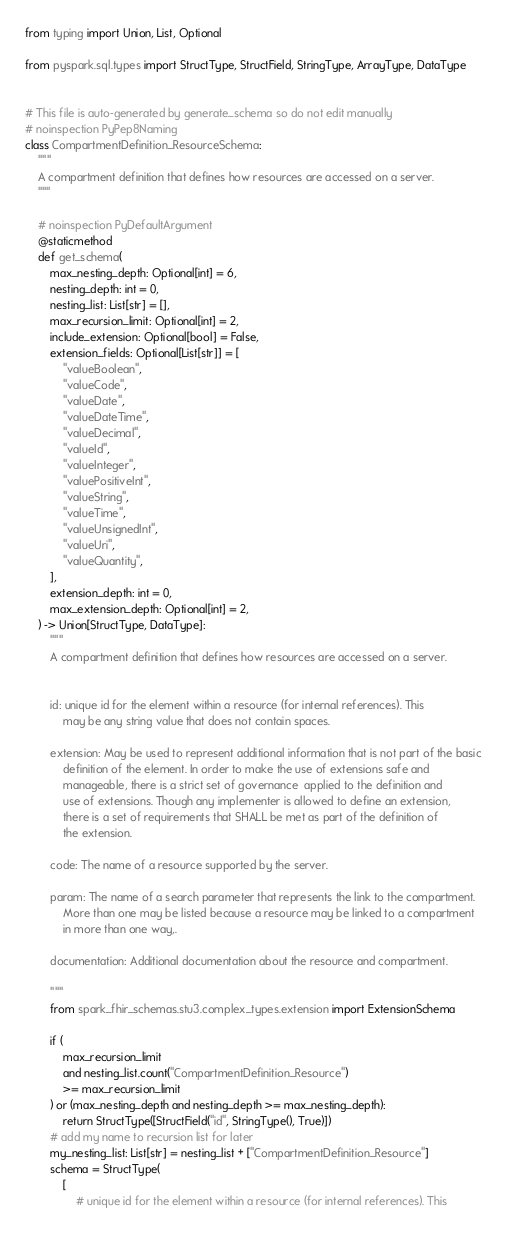<code> <loc_0><loc_0><loc_500><loc_500><_Python_>from typing import Union, List, Optional

from pyspark.sql.types import StructType, StructField, StringType, ArrayType, DataType


# This file is auto-generated by generate_schema so do not edit manually
# noinspection PyPep8Naming
class CompartmentDefinition_ResourceSchema:
    """
    A compartment definition that defines how resources are accessed on a server.
    """

    # noinspection PyDefaultArgument
    @staticmethod
    def get_schema(
        max_nesting_depth: Optional[int] = 6,
        nesting_depth: int = 0,
        nesting_list: List[str] = [],
        max_recursion_limit: Optional[int] = 2,
        include_extension: Optional[bool] = False,
        extension_fields: Optional[List[str]] = [
            "valueBoolean",
            "valueCode",
            "valueDate",
            "valueDateTime",
            "valueDecimal",
            "valueId",
            "valueInteger",
            "valuePositiveInt",
            "valueString",
            "valueTime",
            "valueUnsignedInt",
            "valueUri",
            "valueQuantity",
        ],
        extension_depth: int = 0,
        max_extension_depth: Optional[int] = 2,
    ) -> Union[StructType, DataType]:
        """
        A compartment definition that defines how resources are accessed on a server.


        id: unique id for the element within a resource (for internal references). This
            may be any string value that does not contain spaces.

        extension: May be used to represent additional information that is not part of the basic
            definition of the element. In order to make the use of extensions safe and
            manageable, there is a strict set of governance  applied to the definition and
            use of extensions. Though any implementer is allowed to define an extension,
            there is a set of requirements that SHALL be met as part of the definition of
            the extension.

        code: The name of a resource supported by the server.

        param: The name of a search parameter that represents the link to the compartment.
            More than one may be listed because a resource may be linked to a compartment
            in more than one way,.

        documentation: Additional documentation about the resource and compartment.

        """
        from spark_fhir_schemas.stu3.complex_types.extension import ExtensionSchema

        if (
            max_recursion_limit
            and nesting_list.count("CompartmentDefinition_Resource")
            >= max_recursion_limit
        ) or (max_nesting_depth and nesting_depth >= max_nesting_depth):
            return StructType([StructField("id", StringType(), True)])
        # add my name to recursion list for later
        my_nesting_list: List[str] = nesting_list + ["CompartmentDefinition_Resource"]
        schema = StructType(
            [
                # unique id for the element within a resource (for internal references). This</code> 